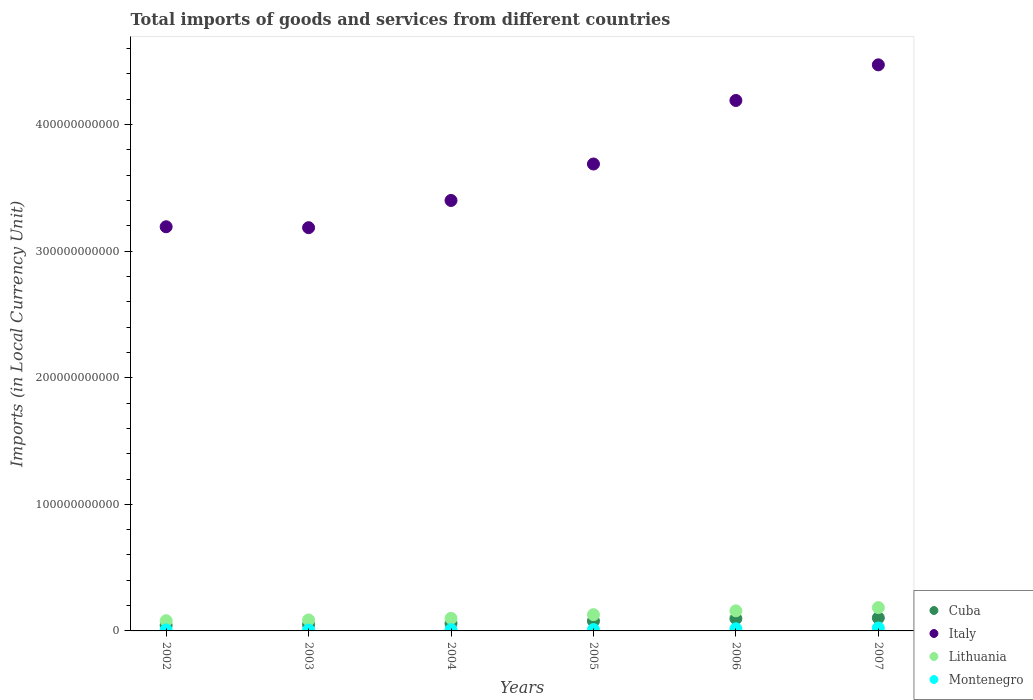Is the number of dotlines equal to the number of legend labels?
Make the answer very short. Yes. What is the Amount of goods and services imports in Montenegro in 2005?
Provide a short and direct response. 1.11e+09. Across all years, what is the maximum Amount of goods and services imports in Montenegro?
Provide a short and direct response. 2.32e+09. Across all years, what is the minimum Amount of goods and services imports in Cuba?
Your answer should be very brief. 4.43e+09. In which year was the Amount of goods and services imports in Cuba maximum?
Offer a terse response. 2007. In which year was the Amount of goods and services imports in Montenegro minimum?
Provide a succinct answer. 2003. What is the total Amount of goods and services imports in Montenegro in the graph?
Make the answer very short. 7.63e+09. What is the difference between the Amount of goods and services imports in Lithuania in 2003 and that in 2005?
Offer a very short reply. -4.17e+09. What is the difference between the Amount of goods and services imports in Lithuania in 2006 and the Amount of goods and services imports in Italy in 2003?
Give a very brief answer. -3.03e+11. What is the average Amount of goods and services imports in Montenegro per year?
Make the answer very short. 1.27e+09. In the year 2005, what is the difference between the Amount of goods and services imports in Cuba and Amount of goods and services imports in Lithuania?
Offer a very short reply. -5.01e+09. In how many years, is the Amount of goods and services imports in Cuba greater than 80000000000 LCU?
Keep it short and to the point. 0. What is the ratio of the Amount of goods and services imports in Italy in 2004 to that in 2005?
Keep it short and to the point. 0.92. What is the difference between the highest and the second highest Amount of goods and services imports in Cuba?
Your answer should be compact. 5.89e+08. What is the difference between the highest and the lowest Amount of goods and services imports in Lithuania?
Ensure brevity in your answer.  1.04e+1. In how many years, is the Amount of goods and services imports in Montenegro greater than the average Amount of goods and services imports in Montenegro taken over all years?
Your answer should be very brief. 2. Is it the case that in every year, the sum of the Amount of goods and services imports in Montenegro and Amount of goods and services imports in Italy  is greater than the Amount of goods and services imports in Lithuania?
Provide a short and direct response. Yes. Does the Amount of goods and services imports in Cuba monotonically increase over the years?
Provide a short and direct response. Yes. How many dotlines are there?
Ensure brevity in your answer.  4. How many years are there in the graph?
Ensure brevity in your answer.  6. What is the difference between two consecutive major ticks on the Y-axis?
Your answer should be compact. 1.00e+11. Are the values on the major ticks of Y-axis written in scientific E-notation?
Make the answer very short. No. Does the graph contain grids?
Ensure brevity in your answer.  No. How are the legend labels stacked?
Keep it short and to the point. Vertical. What is the title of the graph?
Ensure brevity in your answer.  Total imports of goods and services from different countries. What is the label or title of the X-axis?
Offer a very short reply. Years. What is the label or title of the Y-axis?
Give a very brief answer. Imports (in Local Currency Unit). What is the Imports (in Local Currency Unit) in Cuba in 2002?
Offer a terse response. 4.43e+09. What is the Imports (in Local Currency Unit) of Italy in 2002?
Offer a very short reply. 3.19e+11. What is the Imports (in Local Currency Unit) in Lithuania in 2002?
Your response must be concise. 8.06e+09. What is the Imports (in Local Currency Unit) in Montenegro in 2002?
Offer a very short reply. 8.14e+08. What is the Imports (in Local Currency Unit) of Cuba in 2003?
Offer a very short reply. 4.90e+09. What is the Imports (in Local Currency Unit) in Italy in 2003?
Give a very brief answer. 3.19e+11. What is the Imports (in Local Currency Unit) of Lithuania in 2003?
Provide a succinct answer. 8.66e+09. What is the Imports (in Local Currency Unit) in Montenegro in 2003?
Your answer should be compact. 7.10e+08. What is the Imports (in Local Currency Unit) of Cuba in 2004?
Your answer should be very brief. 5.84e+09. What is the Imports (in Local Currency Unit) of Italy in 2004?
Provide a succinct answer. 3.40e+11. What is the Imports (in Local Currency Unit) of Lithuania in 2004?
Give a very brief answer. 9.92e+09. What is the Imports (in Local Currency Unit) of Montenegro in 2004?
Ensure brevity in your answer.  9.70e+08. What is the Imports (in Local Currency Unit) of Cuba in 2005?
Give a very brief answer. 7.82e+09. What is the Imports (in Local Currency Unit) in Italy in 2005?
Ensure brevity in your answer.  3.69e+11. What is the Imports (in Local Currency Unit) in Lithuania in 2005?
Give a very brief answer. 1.28e+1. What is the Imports (in Local Currency Unit) of Montenegro in 2005?
Make the answer very short. 1.11e+09. What is the Imports (in Local Currency Unit) in Cuba in 2006?
Provide a short and direct response. 9.74e+09. What is the Imports (in Local Currency Unit) in Italy in 2006?
Make the answer very short. 4.19e+11. What is the Imports (in Local Currency Unit) in Lithuania in 2006?
Your response must be concise. 1.59e+1. What is the Imports (in Local Currency Unit) in Montenegro in 2006?
Your answer should be very brief. 1.70e+09. What is the Imports (in Local Currency Unit) of Cuba in 2007?
Your response must be concise. 1.03e+1. What is the Imports (in Local Currency Unit) in Italy in 2007?
Offer a very short reply. 4.47e+11. What is the Imports (in Local Currency Unit) in Lithuania in 2007?
Your response must be concise. 1.84e+1. What is the Imports (in Local Currency Unit) in Montenegro in 2007?
Provide a succinct answer. 2.32e+09. Across all years, what is the maximum Imports (in Local Currency Unit) in Cuba?
Offer a very short reply. 1.03e+1. Across all years, what is the maximum Imports (in Local Currency Unit) in Italy?
Offer a very short reply. 4.47e+11. Across all years, what is the maximum Imports (in Local Currency Unit) in Lithuania?
Make the answer very short. 1.84e+1. Across all years, what is the maximum Imports (in Local Currency Unit) of Montenegro?
Provide a succinct answer. 2.32e+09. Across all years, what is the minimum Imports (in Local Currency Unit) in Cuba?
Keep it short and to the point. 4.43e+09. Across all years, what is the minimum Imports (in Local Currency Unit) of Italy?
Your answer should be very brief. 3.19e+11. Across all years, what is the minimum Imports (in Local Currency Unit) in Lithuania?
Ensure brevity in your answer.  8.06e+09. Across all years, what is the minimum Imports (in Local Currency Unit) of Montenegro?
Offer a very short reply. 7.10e+08. What is the total Imports (in Local Currency Unit) of Cuba in the graph?
Offer a terse response. 4.31e+1. What is the total Imports (in Local Currency Unit) in Italy in the graph?
Offer a terse response. 2.21e+12. What is the total Imports (in Local Currency Unit) in Lithuania in the graph?
Your response must be concise. 7.38e+1. What is the total Imports (in Local Currency Unit) of Montenegro in the graph?
Your answer should be very brief. 7.63e+09. What is the difference between the Imports (in Local Currency Unit) in Cuba in 2002 and that in 2003?
Your answer should be compact. -4.60e+08. What is the difference between the Imports (in Local Currency Unit) in Italy in 2002 and that in 2003?
Your response must be concise. 7.24e+08. What is the difference between the Imports (in Local Currency Unit) in Lithuania in 2002 and that in 2003?
Keep it short and to the point. -6.00e+08. What is the difference between the Imports (in Local Currency Unit) in Montenegro in 2002 and that in 2003?
Provide a succinct answer. 1.05e+08. What is the difference between the Imports (in Local Currency Unit) in Cuba in 2002 and that in 2004?
Keep it short and to the point. -1.41e+09. What is the difference between the Imports (in Local Currency Unit) of Italy in 2002 and that in 2004?
Keep it short and to the point. -2.08e+1. What is the difference between the Imports (in Local Currency Unit) of Lithuania in 2002 and that in 2004?
Your answer should be compact. -1.87e+09. What is the difference between the Imports (in Local Currency Unit) in Montenegro in 2002 and that in 2004?
Your answer should be compact. -1.55e+08. What is the difference between the Imports (in Local Currency Unit) in Cuba in 2002 and that in 2005?
Give a very brief answer. -3.39e+09. What is the difference between the Imports (in Local Currency Unit) of Italy in 2002 and that in 2005?
Your answer should be very brief. -4.96e+1. What is the difference between the Imports (in Local Currency Unit) of Lithuania in 2002 and that in 2005?
Make the answer very short. -4.77e+09. What is the difference between the Imports (in Local Currency Unit) of Montenegro in 2002 and that in 2005?
Give a very brief answer. -2.94e+08. What is the difference between the Imports (in Local Currency Unit) of Cuba in 2002 and that in 2006?
Make the answer very short. -5.31e+09. What is the difference between the Imports (in Local Currency Unit) in Italy in 2002 and that in 2006?
Your response must be concise. -9.98e+1. What is the difference between the Imports (in Local Currency Unit) of Lithuania in 2002 and that in 2006?
Provide a succinct answer. -7.81e+09. What is the difference between the Imports (in Local Currency Unit) in Montenegro in 2002 and that in 2006?
Your answer should be compact. -8.85e+08. What is the difference between the Imports (in Local Currency Unit) in Cuba in 2002 and that in 2007?
Offer a terse response. -5.90e+09. What is the difference between the Imports (in Local Currency Unit) in Italy in 2002 and that in 2007?
Make the answer very short. -1.28e+11. What is the difference between the Imports (in Local Currency Unit) in Lithuania in 2002 and that in 2007?
Your response must be concise. -1.04e+1. What is the difference between the Imports (in Local Currency Unit) of Montenegro in 2002 and that in 2007?
Your answer should be compact. -1.51e+09. What is the difference between the Imports (in Local Currency Unit) in Cuba in 2003 and that in 2004?
Give a very brief answer. -9.46e+08. What is the difference between the Imports (in Local Currency Unit) of Italy in 2003 and that in 2004?
Your response must be concise. -2.15e+1. What is the difference between the Imports (in Local Currency Unit) in Lithuania in 2003 and that in 2004?
Offer a terse response. -1.26e+09. What is the difference between the Imports (in Local Currency Unit) of Montenegro in 2003 and that in 2004?
Make the answer very short. -2.60e+08. What is the difference between the Imports (in Local Currency Unit) of Cuba in 2003 and that in 2005?
Offer a very short reply. -2.93e+09. What is the difference between the Imports (in Local Currency Unit) in Italy in 2003 and that in 2005?
Ensure brevity in your answer.  -5.03e+1. What is the difference between the Imports (in Local Currency Unit) of Lithuania in 2003 and that in 2005?
Offer a very short reply. -4.17e+09. What is the difference between the Imports (in Local Currency Unit) of Montenegro in 2003 and that in 2005?
Offer a terse response. -3.99e+08. What is the difference between the Imports (in Local Currency Unit) of Cuba in 2003 and that in 2006?
Offer a terse response. -4.85e+09. What is the difference between the Imports (in Local Currency Unit) of Italy in 2003 and that in 2006?
Provide a short and direct response. -1.01e+11. What is the difference between the Imports (in Local Currency Unit) of Lithuania in 2003 and that in 2006?
Provide a short and direct response. -7.21e+09. What is the difference between the Imports (in Local Currency Unit) of Montenegro in 2003 and that in 2006?
Offer a terse response. -9.90e+08. What is the difference between the Imports (in Local Currency Unit) in Cuba in 2003 and that in 2007?
Your response must be concise. -5.44e+09. What is the difference between the Imports (in Local Currency Unit) in Italy in 2003 and that in 2007?
Offer a terse response. -1.29e+11. What is the difference between the Imports (in Local Currency Unit) of Lithuania in 2003 and that in 2007?
Make the answer very short. -9.78e+09. What is the difference between the Imports (in Local Currency Unit) in Montenegro in 2003 and that in 2007?
Make the answer very short. -1.61e+09. What is the difference between the Imports (in Local Currency Unit) of Cuba in 2004 and that in 2005?
Give a very brief answer. -1.98e+09. What is the difference between the Imports (in Local Currency Unit) in Italy in 2004 and that in 2005?
Offer a very short reply. -2.88e+1. What is the difference between the Imports (in Local Currency Unit) of Lithuania in 2004 and that in 2005?
Make the answer very short. -2.91e+09. What is the difference between the Imports (in Local Currency Unit) in Montenegro in 2004 and that in 2005?
Ensure brevity in your answer.  -1.39e+08. What is the difference between the Imports (in Local Currency Unit) in Cuba in 2004 and that in 2006?
Make the answer very short. -3.90e+09. What is the difference between the Imports (in Local Currency Unit) of Italy in 2004 and that in 2006?
Your answer should be very brief. -7.90e+1. What is the difference between the Imports (in Local Currency Unit) in Lithuania in 2004 and that in 2006?
Ensure brevity in your answer.  -5.94e+09. What is the difference between the Imports (in Local Currency Unit) in Montenegro in 2004 and that in 2006?
Offer a terse response. -7.30e+08. What is the difference between the Imports (in Local Currency Unit) in Cuba in 2004 and that in 2007?
Ensure brevity in your answer.  -4.49e+09. What is the difference between the Imports (in Local Currency Unit) in Italy in 2004 and that in 2007?
Keep it short and to the point. -1.07e+11. What is the difference between the Imports (in Local Currency Unit) in Lithuania in 2004 and that in 2007?
Provide a succinct answer. -8.51e+09. What is the difference between the Imports (in Local Currency Unit) of Montenegro in 2004 and that in 2007?
Your response must be concise. -1.35e+09. What is the difference between the Imports (in Local Currency Unit) in Cuba in 2005 and that in 2006?
Offer a terse response. -1.92e+09. What is the difference between the Imports (in Local Currency Unit) of Italy in 2005 and that in 2006?
Offer a terse response. -5.02e+1. What is the difference between the Imports (in Local Currency Unit) of Lithuania in 2005 and that in 2006?
Ensure brevity in your answer.  -3.04e+09. What is the difference between the Imports (in Local Currency Unit) in Montenegro in 2005 and that in 2006?
Make the answer very short. -5.91e+08. What is the difference between the Imports (in Local Currency Unit) of Cuba in 2005 and that in 2007?
Provide a short and direct response. -2.51e+09. What is the difference between the Imports (in Local Currency Unit) of Italy in 2005 and that in 2007?
Provide a succinct answer. -7.83e+1. What is the difference between the Imports (in Local Currency Unit) of Lithuania in 2005 and that in 2007?
Your response must be concise. -5.61e+09. What is the difference between the Imports (in Local Currency Unit) in Montenegro in 2005 and that in 2007?
Your answer should be very brief. -1.22e+09. What is the difference between the Imports (in Local Currency Unit) in Cuba in 2006 and that in 2007?
Provide a short and direct response. -5.89e+08. What is the difference between the Imports (in Local Currency Unit) of Italy in 2006 and that in 2007?
Your answer should be very brief. -2.82e+1. What is the difference between the Imports (in Local Currency Unit) of Lithuania in 2006 and that in 2007?
Provide a succinct answer. -2.57e+09. What is the difference between the Imports (in Local Currency Unit) in Montenegro in 2006 and that in 2007?
Keep it short and to the point. -6.24e+08. What is the difference between the Imports (in Local Currency Unit) of Cuba in 2002 and the Imports (in Local Currency Unit) of Italy in 2003?
Give a very brief answer. -3.14e+11. What is the difference between the Imports (in Local Currency Unit) of Cuba in 2002 and the Imports (in Local Currency Unit) of Lithuania in 2003?
Provide a succinct answer. -4.23e+09. What is the difference between the Imports (in Local Currency Unit) of Cuba in 2002 and the Imports (in Local Currency Unit) of Montenegro in 2003?
Your response must be concise. 3.73e+09. What is the difference between the Imports (in Local Currency Unit) in Italy in 2002 and the Imports (in Local Currency Unit) in Lithuania in 2003?
Provide a succinct answer. 3.11e+11. What is the difference between the Imports (in Local Currency Unit) of Italy in 2002 and the Imports (in Local Currency Unit) of Montenegro in 2003?
Your answer should be very brief. 3.19e+11. What is the difference between the Imports (in Local Currency Unit) in Lithuania in 2002 and the Imports (in Local Currency Unit) in Montenegro in 2003?
Provide a succinct answer. 7.35e+09. What is the difference between the Imports (in Local Currency Unit) in Cuba in 2002 and the Imports (in Local Currency Unit) in Italy in 2004?
Give a very brief answer. -3.36e+11. What is the difference between the Imports (in Local Currency Unit) in Cuba in 2002 and the Imports (in Local Currency Unit) in Lithuania in 2004?
Offer a terse response. -5.49e+09. What is the difference between the Imports (in Local Currency Unit) in Cuba in 2002 and the Imports (in Local Currency Unit) in Montenegro in 2004?
Ensure brevity in your answer.  3.46e+09. What is the difference between the Imports (in Local Currency Unit) in Italy in 2002 and the Imports (in Local Currency Unit) in Lithuania in 2004?
Provide a succinct answer. 3.09e+11. What is the difference between the Imports (in Local Currency Unit) in Italy in 2002 and the Imports (in Local Currency Unit) in Montenegro in 2004?
Your answer should be compact. 3.18e+11. What is the difference between the Imports (in Local Currency Unit) of Lithuania in 2002 and the Imports (in Local Currency Unit) of Montenegro in 2004?
Your answer should be very brief. 7.09e+09. What is the difference between the Imports (in Local Currency Unit) in Cuba in 2002 and the Imports (in Local Currency Unit) in Italy in 2005?
Offer a very short reply. -3.64e+11. What is the difference between the Imports (in Local Currency Unit) of Cuba in 2002 and the Imports (in Local Currency Unit) of Lithuania in 2005?
Offer a terse response. -8.40e+09. What is the difference between the Imports (in Local Currency Unit) in Cuba in 2002 and the Imports (in Local Currency Unit) in Montenegro in 2005?
Your answer should be very brief. 3.33e+09. What is the difference between the Imports (in Local Currency Unit) of Italy in 2002 and the Imports (in Local Currency Unit) of Lithuania in 2005?
Your answer should be compact. 3.06e+11. What is the difference between the Imports (in Local Currency Unit) of Italy in 2002 and the Imports (in Local Currency Unit) of Montenegro in 2005?
Provide a succinct answer. 3.18e+11. What is the difference between the Imports (in Local Currency Unit) of Lithuania in 2002 and the Imports (in Local Currency Unit) of Montenegro in 2005?
Your answer should be very brief. 6.95e+09. What is the difference between the Imports (in Local Currency Unit) in Cuba in 2002 and the Imports (in Local Currency Unit) in Italy in 2006?
Your answer should be compact. -4.15e+11. What is the difference between the Imports (in Local Currency Unit) in Cuba in 2002 and the Imports (in Local Currency Unit) in Lithuania in 2006?
Provide a succinct answer. -1.14e+1. What is the difference between the Imports (in Local Currency Unit) in Cuba in 2002 and the Imports (in Local Currency Unit) in Montenegro in 2006?
Your answer should be compact. 2.73e+09. What is the difference between the Imports (in Local Currency Unit) of Italy in 2002 and the Imports (in Local Currency Unit) of Lithuania in 2006?
Offer a very short reply. 3.03e+11. What is the difference between the Imports (in Local Currency Unit) in Italy in 2002 and the Imports (in Local Currency Unit) in Montenegro in 2006?
Give a very brief answer. 3.18e+11. What is the difference between the Imports (in Local Currency Unit) in Lithuania in 2002 and the Imports (in Local Currency Unit) in Montenegro in 2006?
Ensure brevity in your answer.  6.36e+09. What is the difference between the Imports (in Local Currency Unit) of Cuba in 2002 and the Imports (in Local Currency Unit) of Italy in 2007?
Keep it short and to the point. -4.43e+11. What is the difference between the Imports (in Local Currency Unit) of Cuba in 2002 and the Imports (in Local Currency Unit) of Lithuania in 2007?
Provide a succinct answer. -1.40e+1. What is the difference between the Imports (in Local Currency Unit) in Cuba in 2002 and the Imports (in Local Currency Unit) in Montenegro in 2007?
Provide a succinct answer. 2.11e+09. What is the difference between the Imports (in Local Currency Unit) in Italy in 2002 and the Imports (in Local Currency Unit) in Lithuania in 2007?
Your answer should be very brief. 3.01e+11. What is the difference between the Imports (in Local Currency Unit) of Italy in 2002 and the Imports (in Local Currency Unit) of Montenegro in 2007?
Your answer should be very brief. 3.17e+11. What is the difference between the Imports (in Local Currency Unit) of Lithuania in 2002 and the Imports (in Local Currency Unit) of Montenegro in 2007?
Offer a very short reply. 5.74e+09. What is the difference between the Imports (in Local Currency Unit) of Cuba in 2003 and the Imports (in Local Currency Unit) of Italy in 2004?
Keep it short and to the point. -3.35e+11. What is the difference between the Imports (in Local Currency Unit) of Cuba in 2003 and the Imports (in Local Currency Unit) of Lithuania in 2004?
Give a very brief answer. -5.03e+09. What is the difference between the Imports (in Local Currency Unit) in Cuba in 2003 and the Imports (in Local Currency Unit) in Montenegro in 2004?
Your answer should be very brief. 3.93e+09. What is the difference between the Imports (in Local Currency Unit) in Italy in 2003 and the Imports (in Local Currency Unit) in Lithuania in 2004?
Ensure brevity in your answer.  3.09e+11. What is the difference between the Imports (in Local Currency Unit) of Italy in 2003 and the Imports (in Local Currency Unit) of Montenegro in 2004?
Ensure brevity in your answer.  3.18e+11. What is the difference between the Imports (in Local Currency Unit) of Lithuania in 2003 and the Imports (in Local Currency Unit) of Montenegro in 2004?
Your response must be concise. 7.69e+09. What is the difference between the Imports (in Local Currency Unit) of Cuba in 2003 and the Imports (in Local Currency Unit) of Italy in 2005?
Ensure brevity in your answer.  -3.64e+11. What is the difference between the Imports (in Local Currency Unit) in Cuba in 2003 and the Imports (in Local Currency Unit) in Lithuania in 2005?
Your answer should be compact. -7.94e+09. What is the difference between the Imports (in Local Currency Unit) in Cuba in 2003 and the Imports (in Local Currency Unit) in Montenegro in 2005?
Your answer should be very brief. 3.79e+09. What is the difference between the Imports (in Local Currency Unit) in Italy in 2003 and the Imports (in Local Currency Unit) in Lithuania in 2005?
Offer a terse response. 3.06e+11. What is the difference between the Imports (in Local Currency Unit) of Italy in 2003 and the Imports (in Local Currency Unit) of Montenegro in 2005?
Make the answer very short. 3.17e+11. What is the difference between the Imports (in Local Currency Unit) of Lithuania in 2003 and the Imports (in Local Currency Unit) of Montenegro in 2005?
Give a very brief answer. 7.55e+09. What is the difference between the Imports (in Local Currency Unit) in Cuba in 2003 and the Imports (in Local Currency Unit) in Italy in 2006?
Provide a short and direct response. -4.14e+11. What is the difference between the Imports (in Local Currency Unit) of Cuba in 2003 and the Imports (in Local Currency Unit) of Lithuania in 2006?
Provide a succinct answer. -1.10e+1. What is the difference between the Imports (in Local Currency Unit) of Cuba in 2003 and the Imports (in Local Currency Unit) of Montenegro in 2006?
Provide a succinct answer. 3.20e+09. What is the difference between the Imports (in Local Currency Unit) in Italy in 2003 and the Imports (in Local Currency Unit) in Lithuania in 2006?
Give a very brief answer. 3.03e+11. What is the difference between the Imports (in Local Currency Unit) in Italy in 2003 and the Imports (in Local Currency Unit) in Montenegro in 2006?
Keep it short and to the point. 3.17e+11. What is the difference between the Imports (in Local Currency Unit) in Lithuania in 2003 and the Imports (in Local Currency Unit) in Montenegro in 2006?
Make the answer very short. 6.96e+09. What is the difference between the Imports (in Local Currency Unit) of Cuba in 2003 and the Imports (in Local Currency Unit) of Italy in 2007?
Your response must be concise. -4.42e+11. What is the difference between the Imports (in Local Currency Unit) in Cuba in 2003 and the Imports (in Local Currency Unit) in Lithuania in 2007?
Your response must be concise. -1.35e+1. What is the difference between the Imports (in Local Currency Unit) of Cuba in 2003 and the Imports (in Local Currency Unit) of Montenegro in 2007?
Ensure brevity in your answer.  2.57e+09. What is the difference between the Imports (in Local Currency Unit) in Italy in 2003 and the Imports (in Local Currency Unit) in Lithuania in 2007?
Your answer should be very brief. 3.00e+11. What is the difference between the Imports (in Local Currency Unit) of Italy in 2003 and the Imports (in Local Currency Unit) of Montenegro in 2007?
Offer a very short reply. 3.16e+11. What is the difference between the Imports (in Local Currency Unit) in Lithuania in 2003 and the Imports (in Local Currency Unit) in Montenegro in 2007?
Your response must be concise. 6.34e+09. What is the difference between the Imports (in Local Currency Unit) of Cuba in 2004 and the Imports (in Local Currency Unit) of Italy in 2005?
Your answer should be very brief. -3.63e+11. What is the difference between the Imports (in Local Currency Unit) of Cuba in 2004 and the Imports (in Local Currency Unit) of Lithuania in 2005?
Your response must be concise. -6.99e+09. What is the difference between the Imports (in Local Currency Unit) in Cuba in 2004 and the Imports (in Local Currency Unit) in Montenegro in 2005?
Give a very brief answer. 4.73e+09. What is the difference between the Imports (in Local Currency Unit) of Italy in 2004 and the Imports (in Local Currency Unit) of Lithuania in 2005?
Your answer should be very brief. 3.27e+11. What is the difference between the Imports (in Local Currency Unit) in Italy in 2004 and the Imports (in Local Currency Unit) in Montenegro in 2005?
Provide a short and direct response. 3.39e+11. What is the difference between the Imports (in Local Currency Unit) in Lithuania in 2004 and the Imports (in Local Currency Unit) in Montenegro in 2005?
Ensure brevity in your answer.  8.82e+09. What is the difference between the Imports (in Local Currency Unit) of Cuba in 2004 and the Imports (in Local Currency Unit) of Italy in 2006?
Make the answer very short. -4.13e+11. What is the difference between the Imports (in Local Currency Unit) in Cuba in 2004 and the Imports (in Local Currency Unit) in Lithuania in 2006?
Keep it short and to the point. -1.00e+1. What is the difference between the Imports (in Local Currency Unit) of Cuba in 2004 and the Imports (in Local Currency Unit) of Montenegro in 2006?
Your answer should be very brief. 4.14e+09. What is the difference between the Imports (in Local Currency Unit) in Italy in 2004 and the Imports (in Local Currency Unit) in Lithuania in 2006?
Provide a short and direct response. 3.24e+11. What is the difference between the Imports (in Local Currency Unit) in Italy in 2004 and the Imports (in Local Currency Unit) in Montenegro in 2006?
Provide a short and direct response. 3.38e+11. What is the difference between the Imports (in Local Currency Unit) of Lithuania in 2004 and the Imports (in Local Currency Unit) of Montenegro in 2006?
Your response must be concise. 8.23e+09. What is the difference between the Imports (in Local Currency Unit) of Cuba in 2004 and the Imports (in Local Currency Unit) of Italy in 2007?
Offer a very short reply. -4.41e+11. What is the difference between the Imports (in Local Currency Unit) of Cuba in 2004 and the Imports (in Local Currency Unit) of Lithuania in 2007?
Offer a very short reply. -1.26e+1. What is the difference between the Imports (in Local Currency Unit) in Cuba in 2004 and the Imports (in Local Currency Unit) in Montenegro in 2007?
Keep it short and to the point. 3.52e+09. What is the difference between the Imports (in Local Currency Unit) in Italy in 2004 and the Imports (in Local Currency Unit) in Lithuania in 2007?
Make the answer very short. 3.22e+11. What is the difference between the Imports (in Local Currency Unit) in Italy in 2004 and the Imports (in Local Currency Unit) in Montenegro in 2007?
Provide a short and direct response. 3.38e+11. What is the difference between the Imports (in Local Currency Unit) of Lithuania in 2004 and the Imports (in Local Currency Unit) of Montenegro in 2007?
Your response must be concise. 7.60e+09. What is the difference between the Imports (in Local Currency Unit) of Cuba in 2005 and the Imports (in Local Currency Unit) of Italy in 2006?
Ensure brevity in your answer.  -4.11e+11. What is the difference between the Imports (in Local Currency Unit) of Cuba in 2005 and the Imports (in Local Currency Unit) of Lithuania in 2006?
Make the answer very short. -8.05e+09. What is the difference between the Imports (in Local Currency Unit) in Cuba in 2005 and the Imports (in Local Currency Unit) in Montenegro in 2006?
Your response must be concise. 6.12e+09. What is the difference between the Imports (in Local Currency Unit) in Italy in 2005 and the Imports (in Local Currency Unit) in Lithuania in 2006?
Ensure brevity in your answer.  3.53e+11. What is the difference between the Imports (in Local Currency Unit) of Italy in 2005 and the Imports (in Local Currency Unit) of Montenegro in 2006?
Provide a succinct answer. 3.67e+11. What is the difference between the Imports (in Local Currency Unit) of Lithuania in 2005 and the Imports (in Local Currency Unit) of Montenegro in 2006?
Provide a short and direct response. 1.11e+1. What is the difference between the Imports (in Local Currency Unit) of Cuba in 2005 and the Imports (in Local Currency Unit) of Italy in 2007?
Your answer should be very brief. -4.39e+11. What is the difference between the Imports (in Local Currency Unit) in Cuba in 2005 and the Imports (in Local Currency Unit) in Lithuania in 2007?
Your response must be concise. -1.06e+1. What is the difference between the Imports (in Local Currency Unit) of Cuba in 2005 and the Imports (in Local Currency Unit) of Montenegro in 2007?
Your answer should be compact. 5.50e+09. What is the difference between the Imports (in Local Currency Unit) in Italy in 2005 and the Imports (in Local Currency Unit) in Lithuania in 2007?
Your response must be concise. 3.50e+11. What is the difference between the Imports (in Local Currency Unit) of Italy in 2005 and the Imports (in Local Currency Unit) of Montenegro in 2007?
Provide a short and direct response. 3.67e+11. What is the difference between the Imports (in Local Currency Unit) of Lithuania in 2005 and the Imports (in Local Currency Unit) of Montenegro in 2007?
Offer a terse response. 1.05e+1. What is the difference between the Imports (in Local Currency Unit) in Cuba in 2006 and the Imports (in Local Currency Unit) in Italy in 2007?
Ensure brevity in your answer.  -4.37e+11. What is the difference between the Imports (in Local Currency Unit) in Cuba in 2006 and the Imports (in Local Currency Unit) in Lithuania in 2007?
Ensure brevity in your answer.  -8.70e+09. What is the difference between the Imports (in Local Currency Unit) of Cuba in 2006 and the Imports (in Local Currency Unit) of Montenegro in 2007?
Your answer should be very brief. 7.42e+09. What is the difference between the Imports (in Local Currency Unit) of Italy in 2006 and the Imports (in Local Currency Unit) of Lithuania in 2007?
Offer a very short reply. 4.01e+11. What is the difference between the Imports (in Local Currency Unit) of Italy in 2006 and the Imports (in Local Currency Unit) of Montenegro in 2007?
Ensure brevity in your answer.  4.17e+11. What is the difference between the Imports (in Local Currency Unit) of Lithuania in 2006 and the Imports (in Local Currency Unit) of Montenegro in 2007?
Ensure brevity in your answer.  1.35e+1. What is the average Imports (in Local Currency Unit) of Cuba per year?
Keep it short and to the point. 7.18e+09. What is the average Imports (in Local Currency Unit) in Italy per year?
Your answer should be very brief. 3.69e+11. What is the average Imports (in Local Currency Unit) of Lithuania per year?
Offer a terse response. 1.23e+1. What is the average Imports (in Local Currency Unit) of Montenegro per year?
Offer a very short reply. 1.27e+09. In the year 2002, what is the difference between the Imports (in Local Currency Unit) of Cuba and Imports (in Local Currency Unit) of Italy?
Make the answer very short. -3.15e+11. In the year 2002, what is the difference between the Imports (in Local Currency Unit) of Cuba and Imports (in Local Currency Unit) of Lithuania?
Give a very brief answer. -3.63e+09. In the year 2002, what is the difference between the Imports (in Local Currency Unit) of Cuba and Imports (in Local Currency Unit) of Montenegro?
Provide a short and direct response. 3.62e+09. In the year 2002, what is the difference between the Imports (in Local Currency Unit) of Italy and Imports (in Local Currency Unit) of Lithuania?
Your answer should be very brief. 3.11e+11. In the year 2002, what is the difference between the Imports (in Local Currency Unit) of Italy and Imports (in Local Currency Unit) of Montenegro?
Provide a succinct answer. 3.18e+11. In the year 2002, what is the difference between the Imports (in Local Currency Unit) of Lithuania and Imports (in Local Currency Unit) of Montenegro?
Offer a terse response. 7.25e+09. In the year 2003, what is the difference between the Imports (in Local Currency Unit) in Cuba and Imports (in Local Currency Unit) in Italy?
Your answer should be very brief. -3.14e+11. In the year 2003, what is the difference between the Imports (in Local Currency Unit) in Cuba and Imports (in Local Currency Unit) in Lithuania?
Make the answer very short. -3.77e+09. In the year 2003, what is the difference between the Imports (in Local Currency Unit) of Cuba and Imports (in Local Currency Unit) of Montenegro?
Your answer should be very brief. 4.19e+09. In the year 2003, what is the difference between the Imports (in Local Currency Unit) of Italy and Imports (in Local Currency Unit) of Lithuania?
Your answer should be compact. 3.10e+11. In the year 2003, what is the difference between the Imports (in Local Currency Unit) in Italy and Imports (in Local Currency Unit) in Montenegro?
Give a very brief answer. 3.18e+11. In the year 2003, what is the difference between the Imports (in Local Currency Unit) in Lithuania and Imports (in Local Currency Unit) in Montenegro?
Provide a short and direct response. 7.95e+09. In the year 2004, what is the difference between the Imports (in Local Currency Unit) of Cuba and Imports (in Local Currency Unit) of Italy?
Offer a very short reply. -3.34e+11. In the year 2004, what is the difference between the Imports (in Local Currency Unit) in Cuba and Imports (in Local Currency Unit) in Lithuania?
Your response must be concise. -4.08e+09. In the year 2004, what is the difference between the Imports (in Local Currency Unit) of Cuba and Imports (in Local Currency Unit) of Montenegro?
Your response must be concise. 4.87e+09. In the year 2004, what is the difference between the Imports (in Local Currency Unit) in Italy and Imports (in Local Currency Unit) in Lithuania?
Offer a very short reply. 3.30e+11. In the year 2004, what is the difference between the Imports (in Local Currency Unit) in Italy and Imports (in Local Currency Unit) in Montenegro?
Your answer should be compact. 3.39e+11. In the year 2004, what is the difference between the Imports (in Local Currency Unit) in Lithuania and Imports (in Local Currency Unit) in Montenegro?
Keep it short and to the point. 8.95e+09. In the year 2005, what is the difference between the Imports (in Local Currency Unit) in Cuba and Imports (in Local Currency Unit) in Italy?
Ensure brevity in your answer.  -3.61e+11. In the year 2005, what is the difference between the Imports (in Local Currency Unit) in Cuba and Imports (in Local Currency Unit) in Lithuania?
Offer a very short reply. -5.01e+09. In the year 2005, what is the difference between the Imports (in Local Currency Unit) in Cuba and Imports (in Local Currency Unit) in Montenegro?
Keep it short and to the point. 6.71e+09. In the year 2005, what is the difference between the Imports (in Local Currency Unit) in Italy and Imports (in Local Currency Unit) in Lithuania?
Offer a terse response. 3.56e+11. In the year 2005, what is the difference between the Imports (in Local Currency Unit) in Italy and Imports (in Local Currency Unit) in Montenegro?
Ensure brevity in your answer.  3.68e+11. In the year 2005, what is the difference between the Imports (in Local Currency Unit) of Lithuania and Imports (in Local Currency Unit) of Montenegro?
Your answer should be compact. 1.17e+1. In the year 2006, what is the difference between the Imports (in Local Currency Unit) in Cuba and Imports (in Local Currency Unit) in Italy?
Your answer should be compact. -4.09e+11. In the year 2006, what is the difference between the Imports (in Local Currency Unit) of Cuba and Imports (in Local Currency Unit) of Lithuania?
Give a very brief answer. -6.12e+09. In the year 2006, what is the difference between the Imports (in Local Currency Unit) of Cuba and Imports (in Local Currency Unit) of Montenegro?
Your response must be concise. 8.04e+09. In the year 2006, what is the difference between the Imports (in Local Currency Unit) in Italy and Imports (in Local Currency Unit) in Lithuania?
Give a very brief answer. 4.03e+11. In the year 2006, what is the difference between the Imports (in Local Currency Unit) in Italy and Imports (in Local Currency Unit) in Montenegro?
Your answer should be very brief. 4.17e+11. In the year 2006, what is the difference between the Imports (in Local Currency Unit) in Lithuania and Imports (in Local Currency Unit) in Montenegro?
Your response must be concise. 1.42e+1. In the year 2007, what is the difference between the Imports (in Local Currency Unit) in Cuba and Imports (in Local Currency Unit) in Italy?
Your response must be concise. -4.37e+11. In the year 2007, what is the difference between the Imports (in Local Currency Unit) of Cuba and Imports (in Local Currency Unit) of Lithuania?
Your response must be concise. -8.11e+09. In the year 2007, what is the difference between the Imports (in Local Currency Unit) in Cuba and Imports (in Local Currency Unit) in Montenegro?
Make the answer very short. 8.01e+09. In the year 2007, what is the difference between the Imports (in Local Currency Unit) of Italy and Imports (in Local Currency Unit) of Lithuania?
Give a very brief answer. 4.29e+11. In the year 2007, what is the difference between the Imports (in Local Currency Unit) in Italy and Imports (in Local Currency Unit) in Montenegro?
Ensure brevity in your answer.  4.45e+11. In the year 2007, what is the difference between the Imports (in Local Currency Unit) in Lithuania and Imports (in Local Currency Unit) in Montenegro?
Offer a very short reply. 1.61e+1. What is the ratio of the Imports (in Local Currency Unit) of Cuba in 2002 to that in 2003?
Make the answer very short. 0.91. What is the ratio of the Imports (in Local Currency Unit) of Lithuania in 2002 to that in 2003?
Your response must be concise. 0.93. What is the ratio of the Imports (in Local Currency Unit) of Montenegro in 2002 to that in 2003?
Make the answer very short. 1.15. What is the ratio of the Imports (in Local Currency Unit) of Cuba in 2002 to that in 2004?
Your answer should be compact. 0.76. What is the ratio of the Imports (in Local Currency Unit) of Italy in 2002 to that in 2004?
Your response must be concise. 0.94. What is the ratio of the Imports (in Local Currency Unit) of Lithuania in 2002 to that in 2004?
Offer a very short reply. 0.81. What is the ratio of the Imports (in Local Currency Unit) in Montenegro in 2002 to that in 2004?
Keep it short and to the point. 0.84. What is the ratio of the Imports (in Local Currency Unit) in Cuba in 2002 to that in 2005?
Your answer should be compact. 0.57. What is the ratio of the Imports (in Local Currency Unit) in Italy in 2002 to that in 2005?
Offer a very short reply. 0.87. What is the ratio of the Imports (in Local Currency Unit) in Lithuania in 2002 to that in 2005?
Keep it short and to the point. 0.63. What is the ratio of the Imports (in Local Currency Unit) in Montenegro in 2002 to that in 2005?
Give a very brief answer. 0.73. What is the ratio of the Imports (in Local Currency Unit) in Cuba in 2002 to that in 2006?
Provide a succinct answer. 0.46. What is the ratio of the Imports (in Local Currency Unit) of Italy in 2002 to that in 2006?
Offer a very short reply. 0.76. What is the ratio of the Imports (in Local Currency Unit) of Lithuania in 2002 to that in 2006?
Your answer should be compact. 0.51. What is the ratio of the Imports (in Local Currency Unit) in Montenegro in 2002 to that in 2006?
Your response must be concise. 0.48. What is the ratio of the Imports (in Local Currency Unit) of Cuba in 2002 to that in 2007?
Give a very brief answer. 0.43. What is the ratio of the Imports (in Local Currency Unit) of Italy in 2002 to that in 2007?
Provide a succinct answer. 0.71. What is the ratio of the Imports (in Local Currency Unit) of Lithuania in 2002 to that in 2007?
Your answer should be very brief. 0.44. What is the ratio of the Imports (in Local Currency Unit) in Montenegro in 2002 to that in 2007?
Provide a short and direct response. 0.35. What is the ratio of the Imports (in Local Currency Unit) of Cuba in 2003 to that in 2004?
Provide a short and direct response. 0.84. What is the ratio of the Imports (in Local Currency Unit) of Italy in 2003 to that in 2004?
Give a very brief answer. 0.94. What is the ratio of the Imports (in Local Currency Unit) in Lithuania in 2003 to that in 2004?
Keep it short and to the point. 0.87. What is the ratio of the Imports (in Local Currency Unit) of Montenegro in 2003 to that in 2004?
Provide a succinct answer. 0.73. What is the ratio of the Imports (in Local Currency Unit) of Cuba in 2003 to that in 2005?
Offer a terse response. 0.63. What is the ratio of the Imports (in Local Currency Unit) in Italy in 2003 to that in 2005?
Give a very brief answer. 0.86. What is the ratio of the Imports (in Local Currency Unit) in Lithuania in 2003 to that in 2005?
Keep it short and to the point. 0.67. What is the ratio of the Imports (in Local Currency Unit) in Montenegro in 2003 to that in 2005?
Provide a short and direct response. 0.64. What is the ratio of the Imports (in Local Currency Unit) of Cuba in 2003 to that in 2006?
Ensure brevity in your answer.  0.5. What is the ratio of the Imports (in Local Currency Unit) of Italy in 2003 to that in 2006?
Offer a terse response. 0.76. What is the ratio of the Imports (in Local Currency Unit) of Lithuania in 2003 to that in 2006?
Offer a very short reply. 0.55. What is the ratio of the Imports (in Local Currency Unit) of Montenegro in 2003 to that in 2006?
Your response must be concise. 0.42. What is the ratio of the Imports (in Local Currency Unit) in Cuba in 2003 to that in 2007?
Provide a short and direct response. 0.47. What is the ratio of the Imports (in Local Currency Unit) of Italy in 2003 to that in 2007?
Your response must be concise. 0.71. What is the ratio of the Imports (in Local Currency Unit) of Lithuania in 2003 to that in 2007?
Ensure brevity in your answer.  0.47. What is the ratio of the Imports (in Local Currency Unit) in Montenegro in 2003 to that in 2007?
Offer a very short reply. 0.31. What is the ratio of the Imports (in Local Currency Unit) of Cuba in 2004 to that in 2005?
Offer a very short reply. 0.75. What is the ratio of the Imports (in Local Currency Unit) of Italy in 2004 to that in 2005?
Give a very brief answer. 0.92. What is the ratio of the Imports (in Local Currency Unit) in Lithuania in 2004 to that in 2005?
Your answer should be very brief. 0.77. What is the ratio of the Imports (in Local Currency Unit) in Montenegro in 2004 to that in 2005?
Provide a short and direct response. 0.88. What is the ratio of the Imports (in Local Currency Unit) of Cuba in 2004 to that in 2006?
Keep it short and to the point. 0.6. What is the ratio of the Imports (in Local Currency Unit) of Italy in 2004 to that in 2006?
Keep it short and to the point. 0.81. What is the ratio of the Imports (in Local Currency Unit) of Lithuania in 2004 to that in 2006?
Offer a very short reply. 0.63. What is the ratio of the Imports (in Local Currency Unit) of Montenegro in 2004 to that in 2006?
Offer a very short reply. 0.57. What is the ratio of the Imports (in Local Currency Unit) of Cuba in 2004 to that in 2007?
Your response must be concise. 0.57. What is the ratio of the Imports (in Local Currency Unit) of Italy in 2004 to that in 2007?
Give a very brief answer. 0.76. What is the ratio of the Imports (in Local Currency Unit) of Lithuania in 2004 to that in 2007?
Keep it short and to the point. 0.54. What is the ratio of the Imports (in Local Currency Unit) of Montenegro in 2004 to that in 2007?
Your response must be concise. 0.42. What is the ratio of the Imports (in Local Currency Unit) in Cuba in 2005 to that in 2006?
Your answer should be compact. 0.8. What is the ratio of the Imports (in Local Currency Unit) of Italy in 2005 to that in 2006?
Keep it short and to the point. 0.88. What is the ratio of the Imports (in Local Currency Unit) of Lithuania in 2005 to that in 2006?
Provide a short and direct response. 0.81. What is the ratio of the Imports (in Local Currency Unit) in Montenegro in 2005 to that in 2006?
Ensure brevity in your answer.  0.65. What is the ratio of the Imports (in Local Currency Unit) of Cuba in 2005 to that in 2007?
Offer a very short reply. 0.76. What is the ratio of the Imports (in Local Currency Unit) of Italy in 2005 to that in 2007?
Your answer should be compact. 0.82. What is the ratio of the Imports (in Local Currency Unit) in Lithuania in 2005 to that in 2007?
Give a very brief answer. 0.7. What is the ratio of the Imports (in Local Currency Unit) of Montenegro in 2005 to that in 2007?
Your answer should be compact. 0.48. What is the ratio of the Imports (in Local Currency Unit) in Cuba in 2006 to that in 2007?
Ensure brevity in your answer.  0.94. What is the ratio of the Imports (in Local Currency Unit) of Italy in 2006 to that in 2007?
Offer a very short reply. 0.94. What is the ratio of the Imports (in Local Currency Unit) of Lithuania in 2006 to that in 2007?
Provide a succinct answer. 0.86. What is the ratio of the Imports (in Local Currency Unit) in Montenegro in 2006 to that in 2007?
Keep it short and to the point. 0.73. What is the difference between the highest and the second highest Imports (in Local Currency Unit) in Cuba?
Ensure brevity in your answer.  5.89e+08. What is the difference between the highest and the second highest Imports (in Local Currency Unit) of Italy?
Ensure brevity in your answer.  2.82e+1. What is the difference between the highest and the second highest Imports (in Local Currency Unit) of Lithuania?
Provide a succinct answer. 2.57e+09. What is the difference between the highest and the second highest Imports (in Local Currency Unit) of Montenegro?
Your answer should be compact. 6.24e+08. What is the difference between the highest and the lowest Imports (in Local Currency Unit) of Cuba?
Provide a short and direct response. 5.90e+09. What is the difference between the highest and the lowest Imports (in Local Currency Unit) in Italy?
Provide a short and direct response. 1.29e+11. What is the difference between the highest and the lowest Imports (in Local Currency Unit) of Lithuania?
Give a very brief answer. 1.04e+1. What is the difference between the highest and the lowest Imports (in Local Currency Unit) in Montenegro?
Your response must be concise. 1.61e+09. 